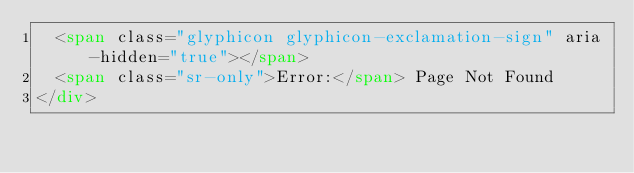Convert code to text. <code><loc_0><loc_0><loc_500><loc_500><_HTML_>	<span class="glyphicon glyphicon-exclamation-sign" aria-hidden="true"></span>
	<span class="sr-only">Error:</span> Page Not Found
</div></code> 